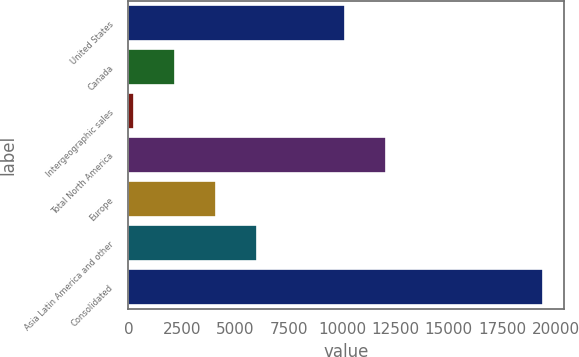<chart> <loc_0><loc_0><loc_500><loc_500><bar_chart><fcel>United States<fcel>Canada<fcel>Intergeographic sales<fcel>Total North America<fcel>Europe<fcel>Asia Latin America and other<fcel>Consolidated<nl><fcel>10143<fcel>2171.9<fcel>256<fcel>12058.9<fcel>4087.8<fcel>6003.7<fcel>19415<nl></chart> 